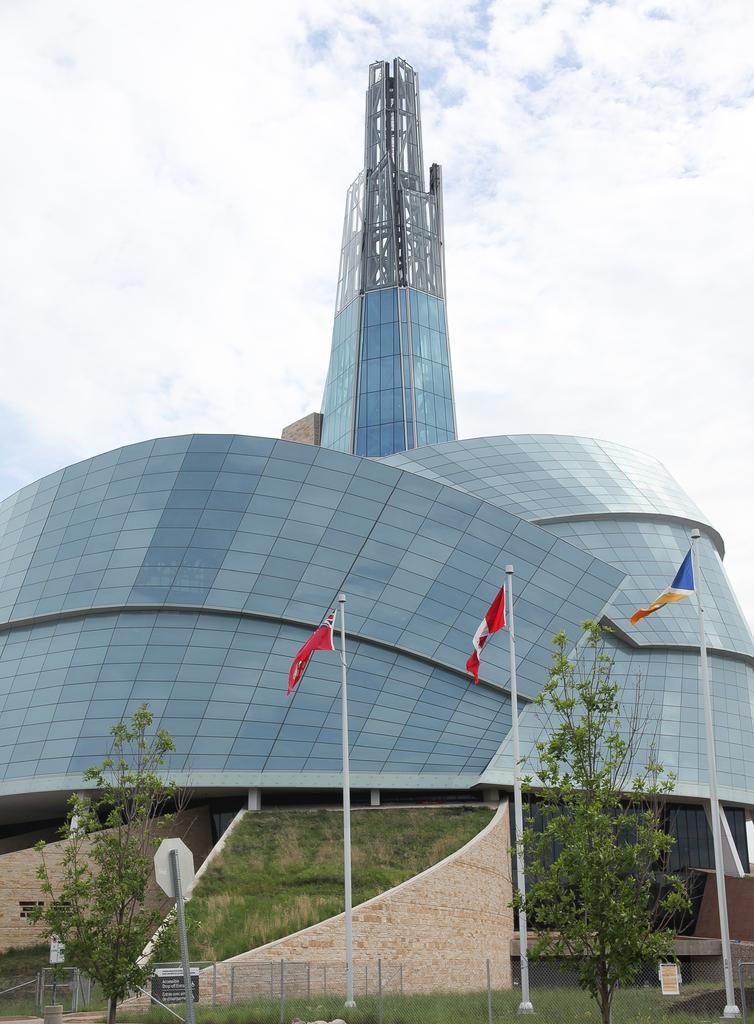Could you give a brief overview of what you see in this image? In this image I can see few poles, few flags, few trees, grass and a building. In background I can see cloudy sky and here I can see something is written. 